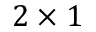Convert formula to latex. <formula><loc_0><loc_0><loc_500><loc_500>2 \times 1</formula> 